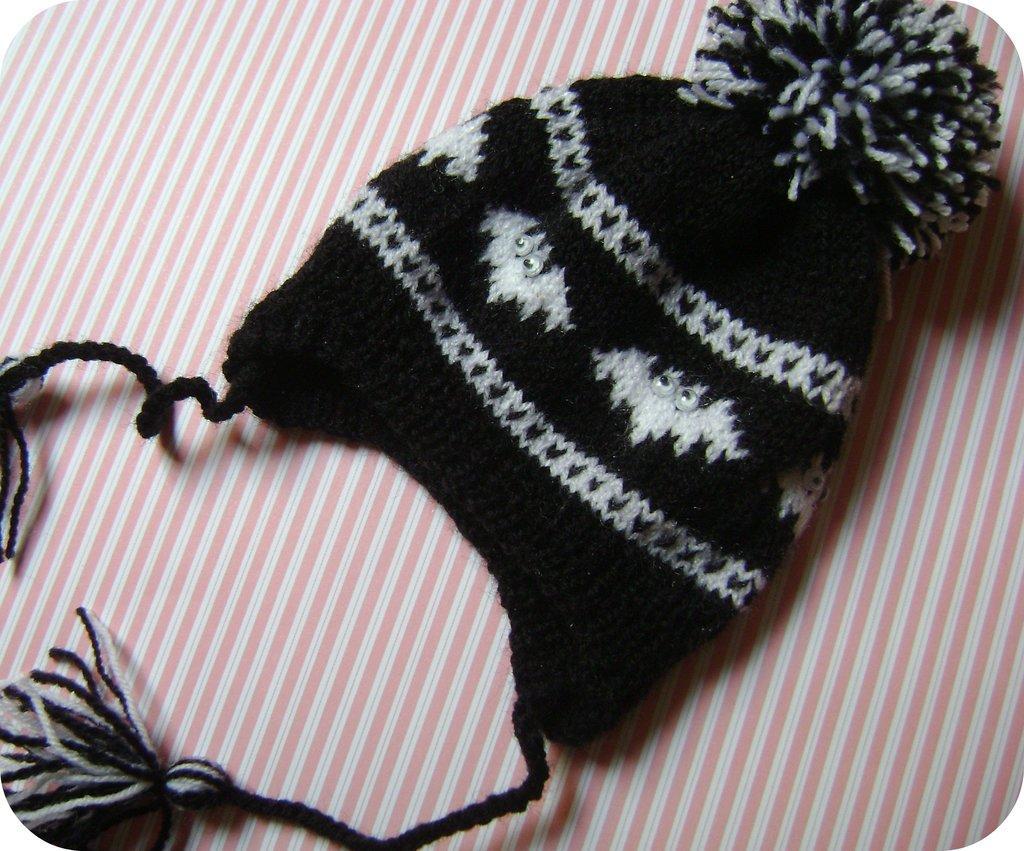In one or two sentences, can you explain what this image depicts? In this image, we can see a finger looping hat on the table. 